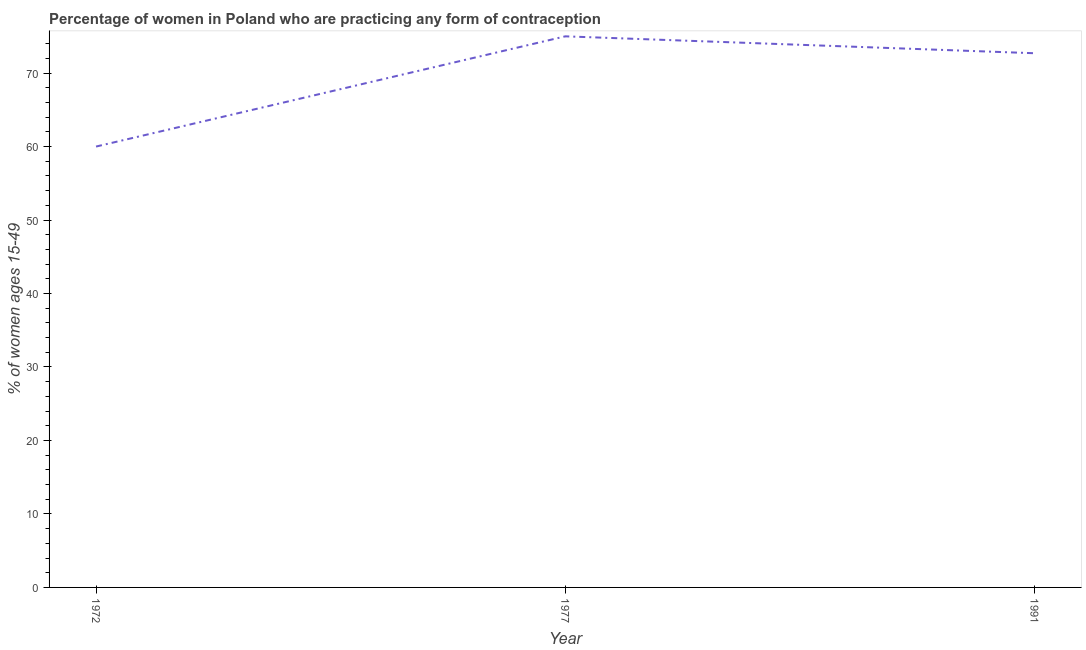What is the contraceptive prevalence in 1991?
Offer a terse response. 72.7. In which year was the contraceptive prevalence maximum?
Give a very brief answer. 1977. In which year was the contraceptive prevalence minimum?
Your answer should be very brief. 1972. What is the sum of the contraceptive prevalence?
Provide a succinct answer. 207.7. What is the difference between the contraceptive prevalence in 1977 and 1991?
Ensure brevity in your answer.  2.3. What is the average contraceptive prevalence per year?
Your answer should be compact. 69.23. What is the median contraceptive prevalence?
Your response must be concise. 72.7. In how many years, is the contraceptive prevalence greater than 10 %?
Make the answer very short. 3. Do a majority of the years between 1972 and 1991 (inclusive) have contraceptive prevalence greater than 58 %?
Provide a short and direct response. Yes. What is the ratio of the contraceptive prevalence in 1977 to that in 1991?
Keep it short and to the point. 1.03. What is the difference between the highest and the second highest contraceptive prevalence?
Ensure brevity in your answer.  2.3. Is the sum of the contraceptive prevalence in 1972 and 1977 greater than the maximum contraceptive prevalence across all years?
Make the answer very short. Yes. What is the difference between the highest and the lowest contraceptive prevalence?
Provide a short and direct response. 15. How many years are there in the graph?
Give a very brief answer. 3. What is the difference between two consecutive major ticks on the Y-axis?
Your response must be concise. 10. Are the values on the major ticks of Y-axis written in scientific E-notation?
Give a very brief answer. No. What is the title of the graph?
Provide a short and direct response. Percentage of women in Poland who are practicing any form of contraception. What is the label or title of the X-axis?
Offer a terse response. Year. What is the label or title of the Y-axis?
Offer a terse response. % of women ages 15-49. What is the % of women ages 15-49 of 1977?
Give a very brief answer. 75. What is the % of women ages 15-49 of 1991?
Provide a short and direct response. 72.7. What is the difference between the % of women ages 15-49 in 1972 and 1977?
Keep it short and to the point. -15. What is the ratio of the % of women ages 15-49 in 1972 to that in 1977?
Offer a very short reply. 0.8. What is the ratio of the % of women ages 15-49 in 1972 to that in 1991?
Give a very brief answer. 0.82. What is the ratio of the % of women ages 15-49 in 1977 to that in 1991?
Provide a short and direct response. 1.03. 